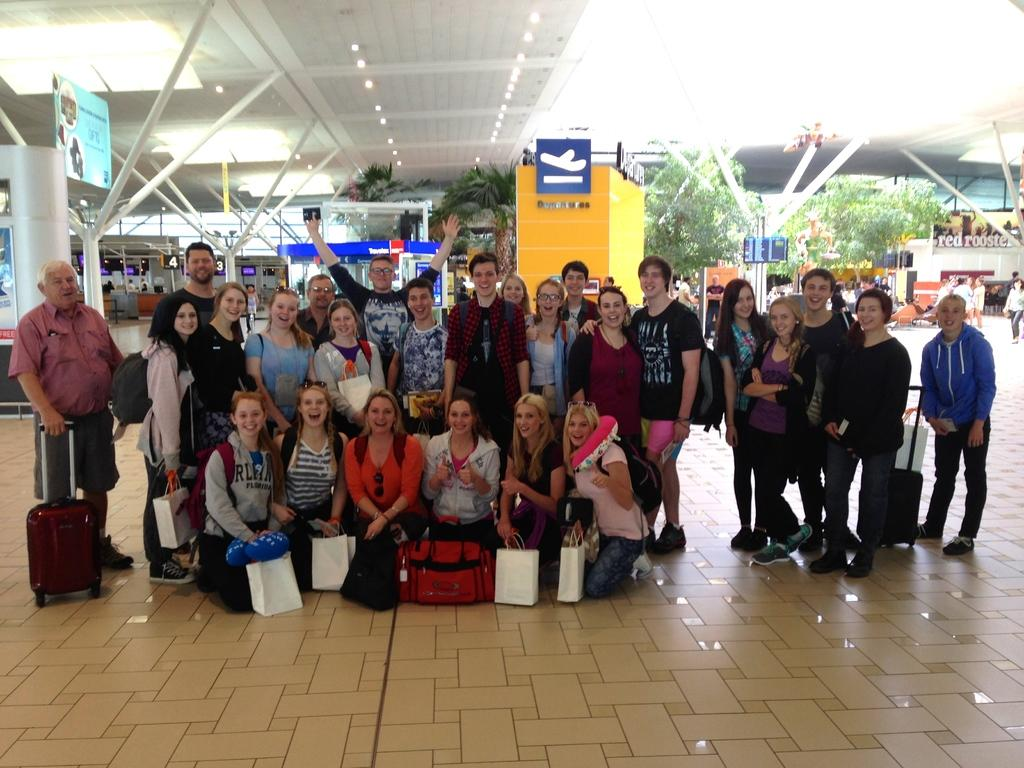How many people are in the image? There is a group of persons in the image. What are the people in the image doing? Some of the persons are standing, while others are kneeling down. What can be seen in the background of the image? There are trees and shops in the background of the image. What type of bedroom furniture can be seen in the image? There is no bedroom furniture present in the image. How is the distribution of people in the image organized? The distribution of people in the image is not mentioned in the provided facts, so it cannot be determined. 